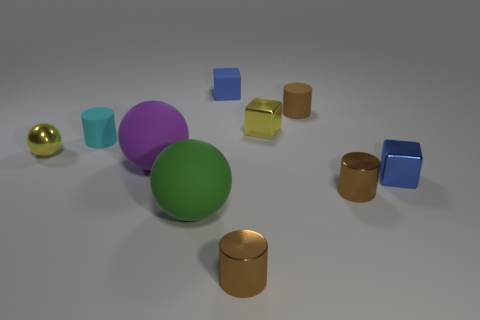What is the material of the tiny cube that is in front of the blue rubber object and behind the small cyan matte cylinder? metal 